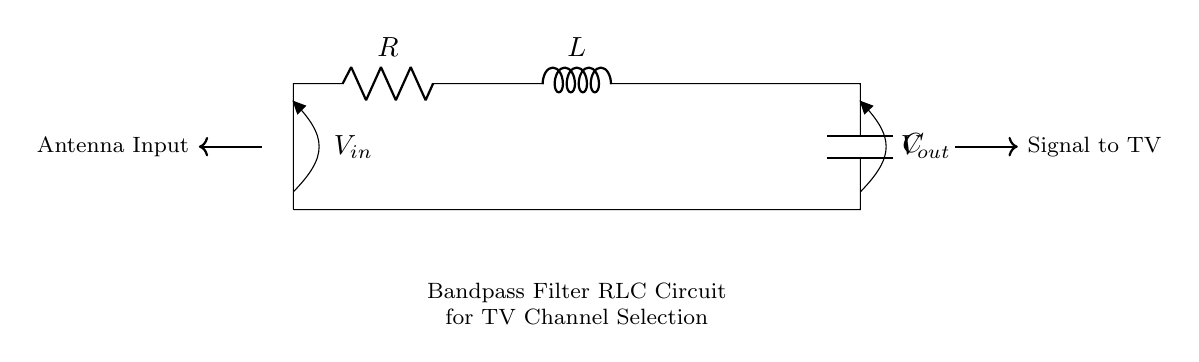What components are present in this circuit? The circuit contains a resistor, inductor, and capacitor, which are essential components for forming a bandpass filter.
Answer: Resistor, Inductor, Capacitor What is the input voltage source labeled as in the circuit? The input voltage source is labeled as V_in, indicating where the signal enters the circuit.
Answer: V_in What is the output voltage indicated in the circuit? The output voltage is labeled as V_out, which is the signal measured after passing through the filter circuit.
Answer: V_out How many components are connected in series in this RLC configuration? The resistor, inductor, and capacitor are connected in series, resulting in a total of three components in a single path.
Answer: Three Why is this circuit classified as a bandpass filter? A bandpass filter allows signals within a specific frequency range to pass while attenuating signals outside that range. The combination of R, L, and C creates this function.
Answer: It allows specific frequency signals What role does the inductor play in this RLC circuit? The inductor stores energy in a magnetic field and influences the circuit's impedance, which is crucial for determining the resonance and overall frequency response of the filter.
Answer: Energy storage and impedance influence 